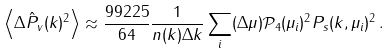Convert formula to latex. <formula><loc_0><loc_0><loc_500><loc_500>\left \langle \Delta \hat { P } _ { v } ( k ) ^ { 2 } \right \rangle \approx \frac { 9 9 2 2 5 } { 6 4 } \frac { 1 } { n ( k ) \Delta k } \sum _ { i } ( \Delta \mu ) \mathcal { P } _ { 4 } ( \mu _ { i } ) ^ { 2 } P _ { s } ( k , \mu _ { i } ) ^ { 2 } \, .</formula> 